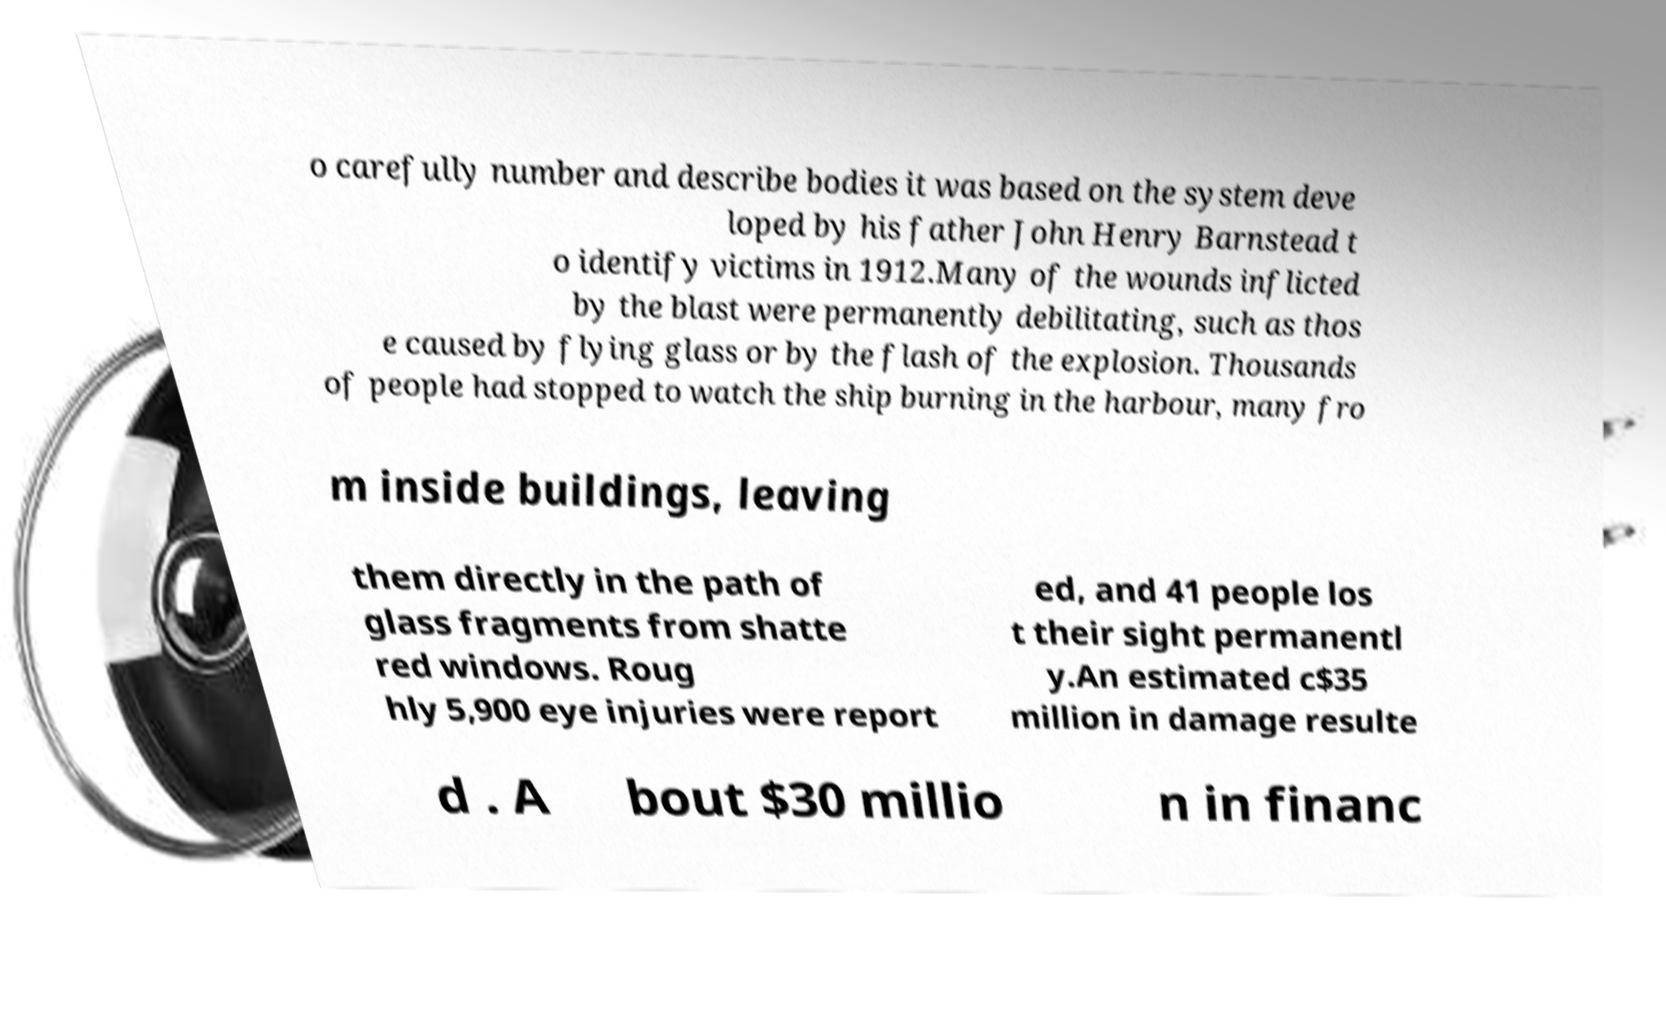Could you extract and type out the text from this image? o carefully number and describe bodies it was based on the system deve loped by his father John Henry Barnstead t o identify victims in 1912.Many of the wounds inflicted by the blast were permanently debilitating, such as thos e caused by flying glass or by the flash of the explosion. Thousands of people had stopped to watch the ship burning in the harbour, many fro m inside buildings, leaving them directly in the path of glass fragments from shatte red windows. Roug hly 5,900 eye injuries were report ed, and 41 people los t their sight permanentl y.An estimated c$35 million in damage resulte d . A bout $30 millio n in financ 